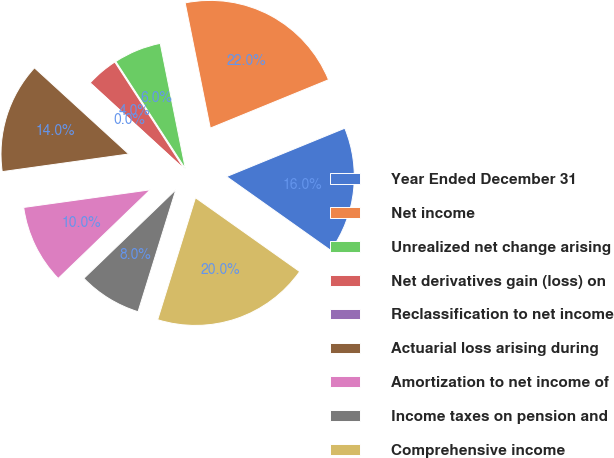<chart> <loc_0><loc_0><loc_500><loc_500><pie_chart><fcel>Year Ended December 31<fcel>Net income<fcel>Unrealized net change arising<fcel>Net derivatives gain (loss) on<fcel>Reclassification to net income<fcel>Actuarial loss arising during<fcel>Amortization to net income of<fcel>Income taxes on pension and<fcel>Comprehensive income<nl><fcel>15.99%<fcel>21.97%<fcel>6.01%<fcel>4.02%<fcel>0.03%<fcel>13.99%<fcel>10.0%<fcel>8.01%<fcel>19.97%<nl></chart> 